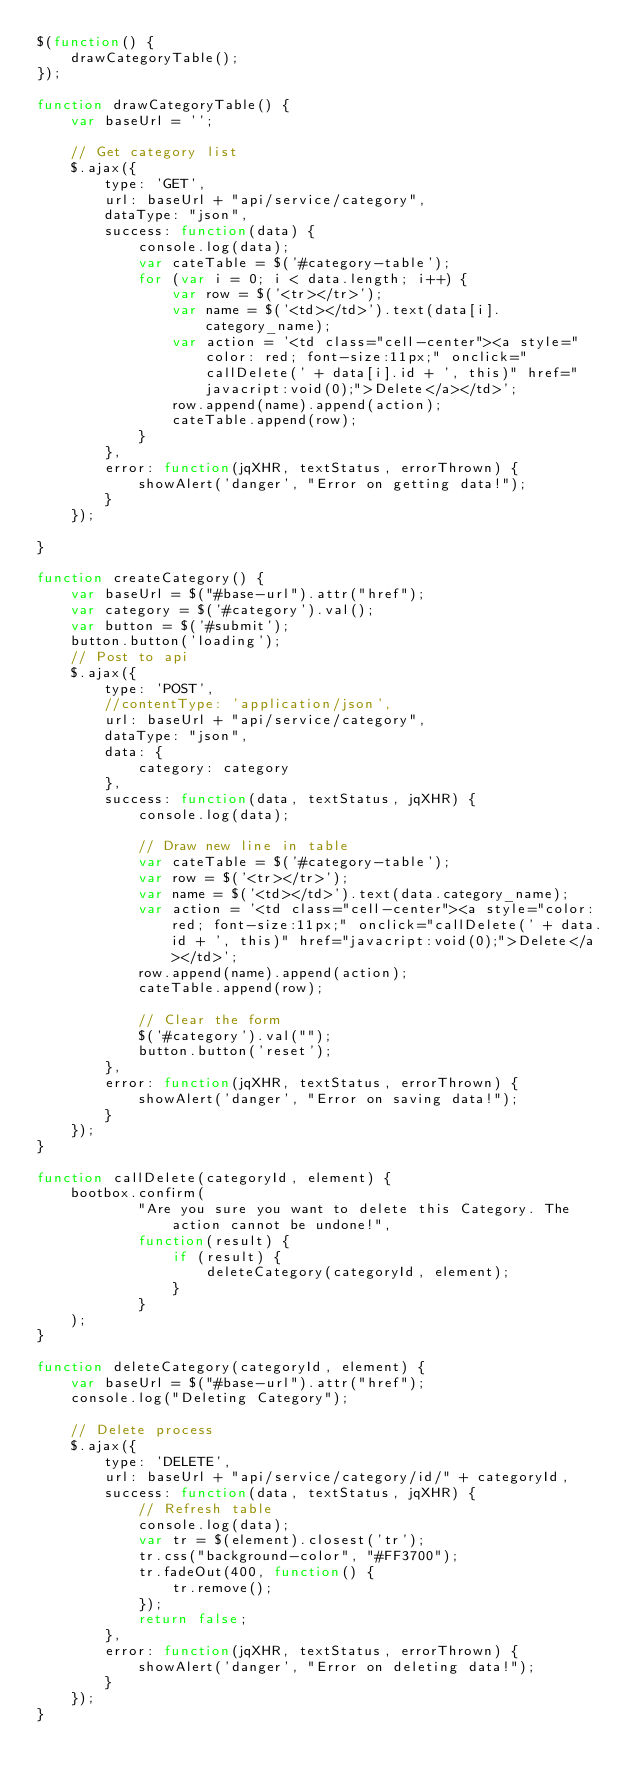Convert code to text. <code><loc_0><loc_0><loc_500><loc_500><_JavaScript_>$(function() {
    drawCategoryTable();
});

function drawCategoryTable() {
    var baseUrl = '';

    // Get category list
    $.ajax({
        type: 'GET',
        url: baseUrl + "api/service/category",
        dataType: "json",
        success: function(data) {
            console.log(data);
            var cateTable = $('#category-table');
            for (var i = 0; i < data.length; i++) {
                var row = $('<tr></tr>');
                var name = $('<td></td>').text(data[i].category_name);
                var action = '<td class="cell-center"><a style="color: red; font-size:11px;" onclick="callDelete(' + data[i].id + ', this)" href="javacript:void(0);">Delete</a></td>';
                row.append(name).append(action);
                cateTable.append(row);
            }
        },
        error: function(jqXHR, textStatus, errorThrown) {
            showAlert('danger', "Error on getting data!");
        }
    });

}

function createCategory() {
    var baseUrl = $("#base-url").attr("href");
    var category = $('#category').val();
    var button = $('#submit');
    button.button('loading');
    // Post to api
    $.ajax({
        type: 'POST',
        //contentType: 'application/json',
        url: baseUrl + "api/service/category",
        dataType: "json",
        data: {
            category: category
        },
        success: function(data, textStatus, jqXHR) {
            console.log(data);

            // Draw new line in table
            var cateTable = $('#category-table');
            var row = $('<tr></tr>');
            var name = $('<td></td>').text(data.category_name);
            var action = '<td class="cell-center"><a style="color: red; font-size:11px;" onclick="callDelete(' + data.id + ', this)" href="javacript:void(0);">Delete</a></td>';
            row.append(name).append(action);
            cateTable.append(row);

            // Clear the form
            $('#category').val("");
            button.button('reset');
        },
        error: function(jqXHR, textStatus, errorThrown) {
            showAlert('danger', "Error on saving data!");
        }
    });
}

function callDelete(categoryId, element) {
    bootbox.confirm(
            "Are you sure you want to delete this Category. The action cannot be undone!",
            function(result) {
                if (result) {
                    deleteCategory(categoryId, element);
                }
            }
    );
}

function deleteCategory(categoryId, element) {
    var baseUrl = $("#base-url").attr("href");
    console.log("Deleting Category");

    // Delete process
    $.ajax({
        type: 'DELETE',
        url: baseUrl + "api/service/category/id/" + categoryId,
        success: function(data, textStatus, jqXHR) {
            // Refresh table
            console.log(data);
            var tr = $(element).closest('tr');
            tr.css("background-color", "#FF3700");
            tr.fadeOut(400, function() {
                tr.remove();
            });
            return false;
        },
        error: function(jqXHR, textStatus, errorThrown) {
            showAlert('danger', "Error on deleting data!");
        }
    });
}
</code> 